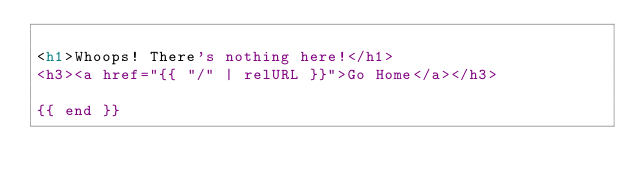<code> <loc_0><loc_0><loc_500><loc_500><_HTML_>
<h1>Whoops! There's nothing here!</h1>
<h3><a href="{{ "/" | relURL }}">Go Home</a></h3>

{{ end }}
</code> 